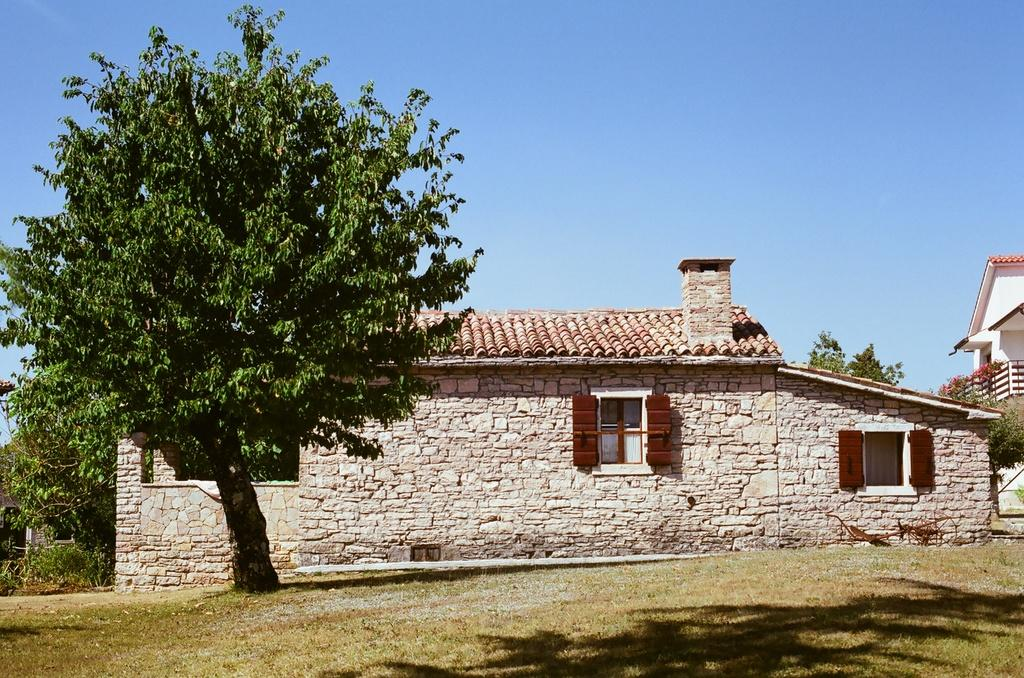What type of structure is present in the image? There is a building in the image. What features can be observed on the building? The building has windows and a chimney. What other elements are visible in the image besides the building? There are trees, the ground, and the sky visible in the image. How many prisoners can be seen in the image? There are no prisoners present in the image; it features a building with windows and a chimney, along with trees, the ground, and the sky. What time of day is it in the image, based on the stomach of the person depicted? There is no person or stomach present in the image; it only features a building, trees, the ground, and the sky. 